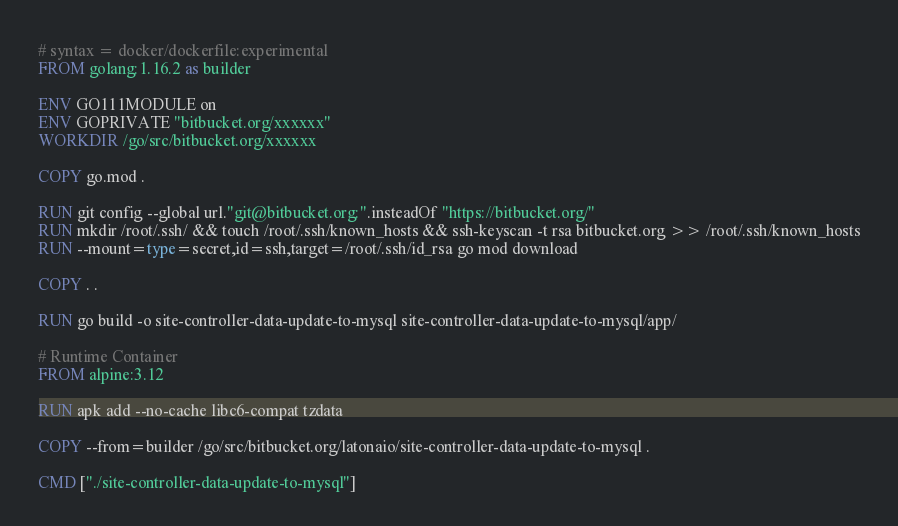Convert code to text. <code><loc_0><loc_0><loc_500><loc_500><_Dockerfile_># syntax = docker/dockerfile:experimental
FROM golang:1.16.2 as builder

ENV GO111MODULE on
ENV GOPRIVATE "bitbucket.org/xxxxxx"
WORKDIR /go/src/bitbucket.org/xxxxxx

COPY go.mod .

RUN git config --global url."git@bitbucket.org:".insteadOf "https://bitbucket.org/"
RUN mkdir /root/.ssh/ && touch /root/.ssh/known_hosts && ssh-keyscan -t rsa bitbucket.org >> /root/.ssh/known_hosts
RUN --mount=type=secret,id=ssh,target=/root/.ssh/id_rsa go mod download

COPY . .

RUN go build -o site-controller-data-update-to-mysql site-controller-data-update-to-mysql/app/

# Runtime Container
FROM alpine:3.12

RUN apk add --no-cache libc6-compat tzdata

COPY --from=builder /go/src/bitbucket.org/latonaio/site-controller-data-update-to-mysql .

CMD ["./site-controller-data-update-to-mysql"]

</code> 